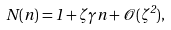<formula> <loc_0><loc_0><loc_500><loc_500>N ( n ) = 1 + \zeta \gamma n + \mathcal { O } ( \zeta ^ { 2 } ) ,</formula> 